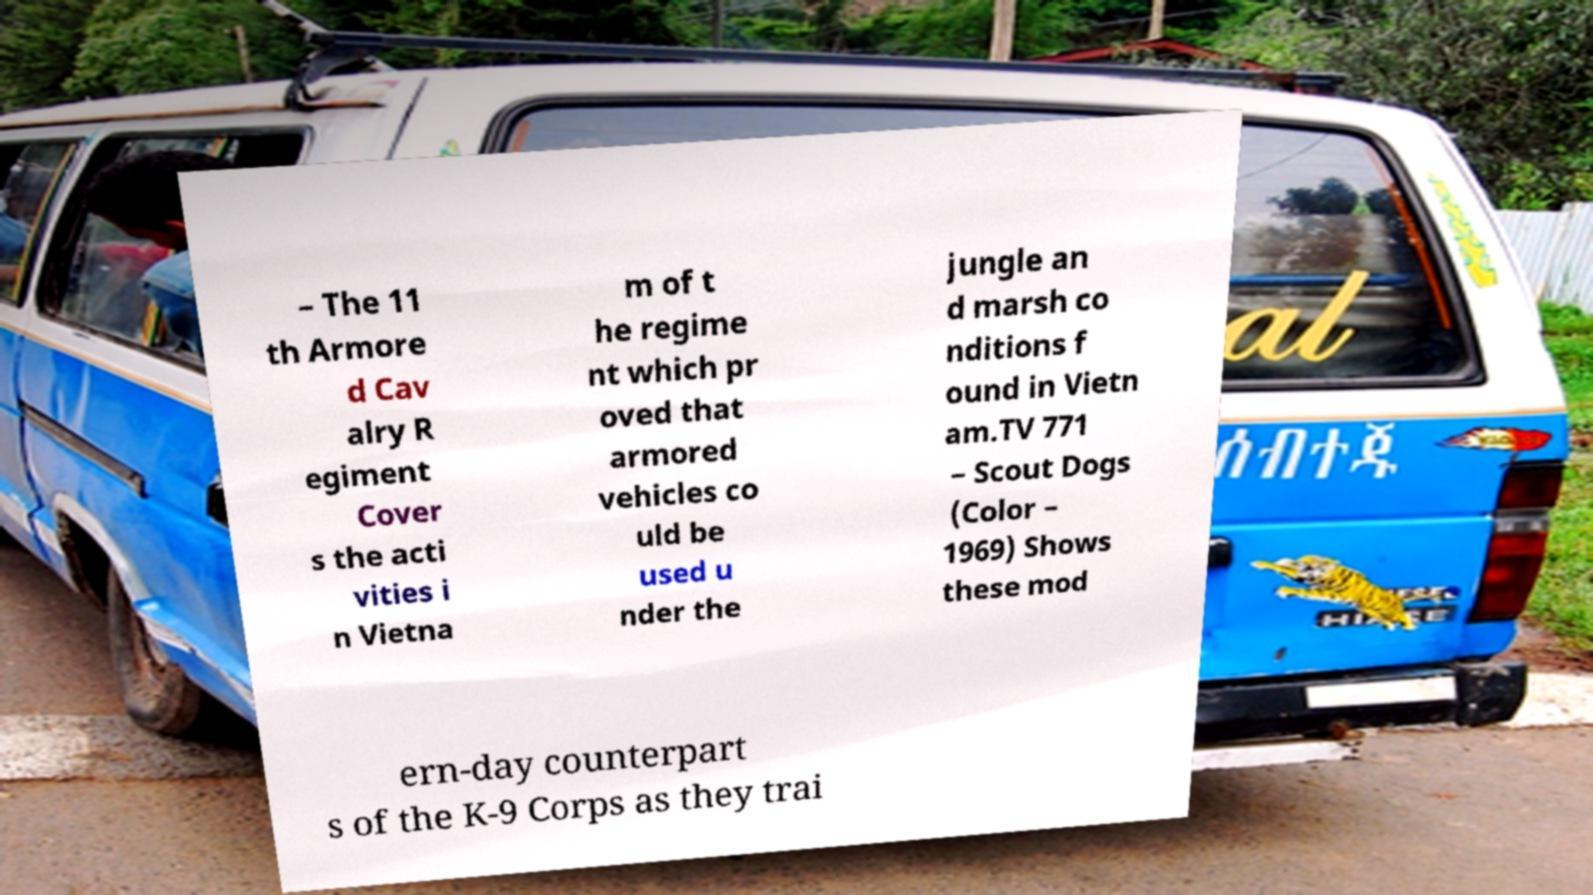Could you extract and type out the text from this image? – The 11 th Armore d Cav alry R egiment Cover s the acti vities i n Vietna m of t he regime nt which pr oved that armored vehicles co uld be used u nder the jungle an d marsh co nditions f ound in Vietn am.TV 771 – Scout Dogs (Color – 1969) Shows these mod ern-day counterpart s of the K-9 Corps as they trai 